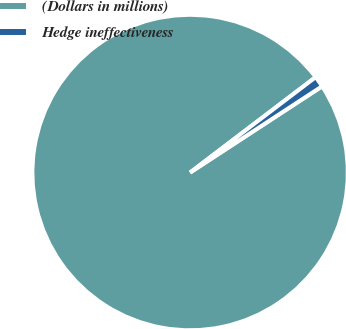Convert chart. <chart><loc_0><loc_0><loc_500><loc_500><pie_chart><fcel>(Dollars in millions)<fcel>Hedge ineffectiveness<nl><fcel>98.87%<fcel>1.13%<nl></chart> 